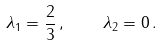Convert formula to latex. <formula><loc_0><loc_0><loc_500><loc_500>\lambda _ { 1 } = \frac { 2 } { 3 } \, , \quad \lambda _ { 2 } = 0 \, .</formula> 